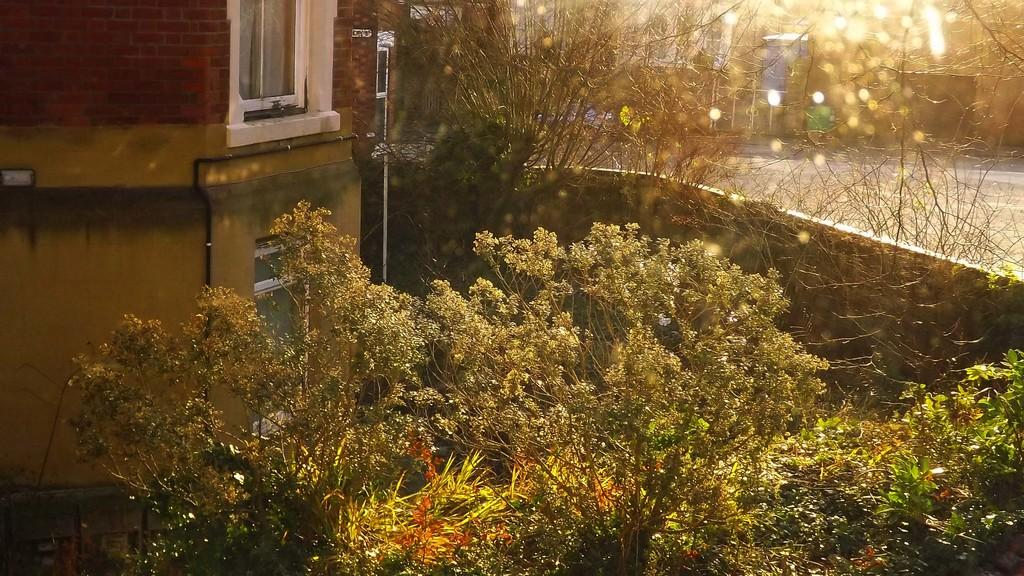What type of natural elements can be seen in the image? There are trees in the image. What type of man-made structure is present in the image? There is a building in the image. What architectural feature can be seen in the image? There is a wall in the image. How would you describe the background of the image? The background of the image is blurry. Can you tell me where your dad is standing in the image? There is no person, let alone a specific individual like your dad, present in the image. How intense is the rainstorm in the image? There is no rainstorm present in the image; it features trees, a building, and a wall. 